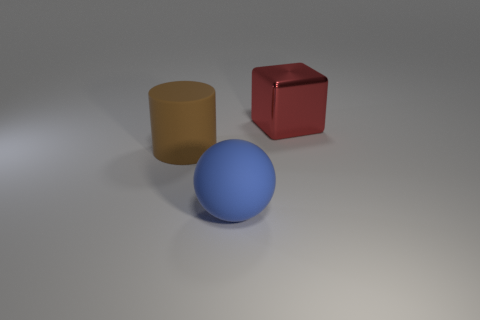Are there any other things that are made of the same material as the red object?
Ensure brevity in your answer.  No. What number of other objects are the same material as the cube?
Your answer should be very brief. 0. Is the number of big matte things on the right side of the large red metal thing the same as the number of big red metallic blocks?
Offer a very short reply. No. The brown object that is the same size as the red cube is what shape?
Provide a succinct answer. Cylinder. There is a red thing; is it the same size as the brown matte object behind the large blue sphere?
Provide a short and direct response. Yes. How many objects are either big objects to the left of the big red metallic object or large red shiny things?
Offer a terse response. 3. There is a big object behind the cylinder; what is its shape?
Keep it short and to the point. Cube. Are there the same number of large red things in front of the large metallic object and large brown cylinders that are behind the big brown rubber thing?
Your answer should be very brief. Yes. There is a thing that is in front of the red block and behind the large blue ball; what is its color?
Ensure brevity in your answer.  Brown. There is a big thing that is left of the rubber object that is in front of the brown cylinder; what is it made of?
Ensure brevity in your answer.  Rubber. 